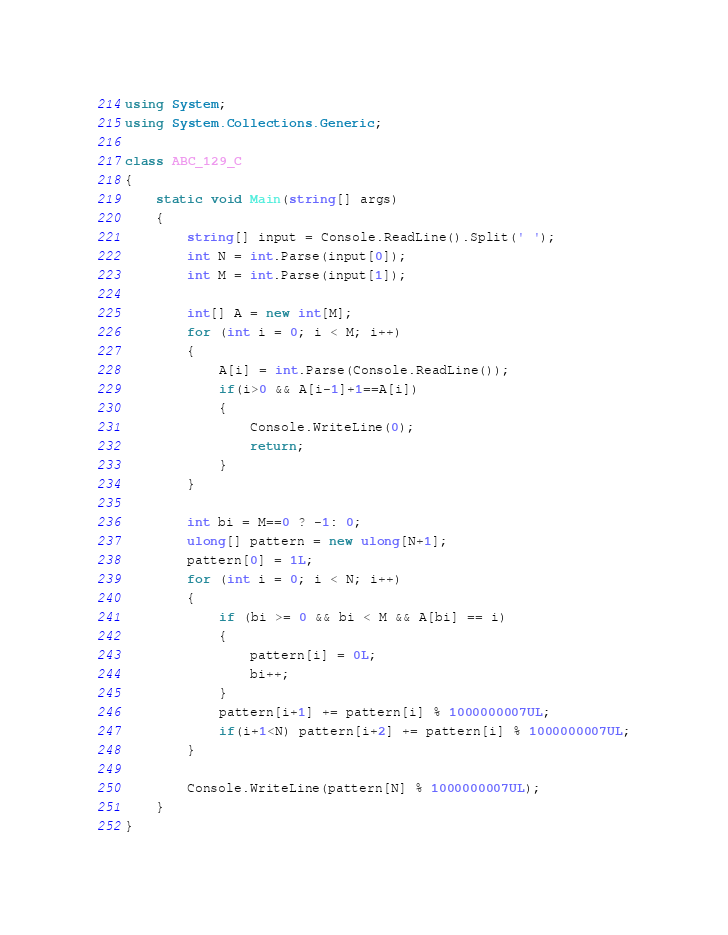<code> <loc_0><loc_0><loc_500><loc_500><_C#_>using System;
using System.Collections.Generic;

class ABC_129_C
{
    static void Main(string[] args)
    {
        string[] input = Console.ReadLine().Split(' ');
        int N = int.Parse(input[0]);
        int M = int.Parse(input[1]);

        int[] A = new int[M];
        for (int i = 0; i < M; i++)
        {
            A[i] = int.Parse(Console.ReadLine());
            if(i>0 && A[i-1]+1==A[i])
            {
                Console.WriteLine(0);
                return;
            }
        }

        int bi = M==0 ? -1: 0;
        ulong[] pattern = new ulong[N+1];
        pattern[0] = 1L;
        for (int i = 0; i < N; i++)
        {
            if (bi >= 0 && bi < M && A[bi] == i)
            {
                pattern[i] = 0L;
                bi++;
            }
            pattern[i+1] += pattern[i] % 1000000007UL;
            if(i+1<N) pattern[i+2] += pattern[i] % 1000000007UL;
        }

        Console.WriteLine(pattern[N] % 1000000007UL);
    }
}</code> 